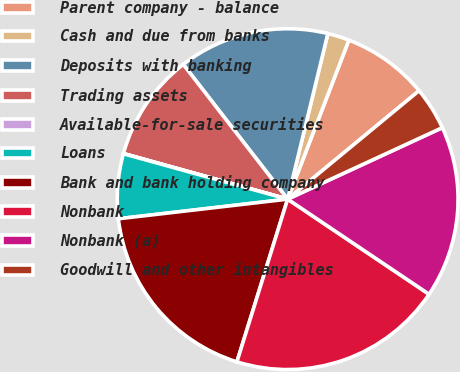<chart> <loc_0><loc_0><loc_500><loc_500><pie_chart><fcel>Parent company - balance<fcel>Cash and due from banks<fcel>Deposits with banking<fcel>Trading assets<fcel>Available-for-sale securities<fcel>Loans<fcel>Bank and bank holding company<fcel>Nonbank<fcel>Nonbank (a)<fcel>Goodwill and other intangibles<nl><fcel>8.17%<fcel>2.06%<fcel>14.28%<fcel>10.2%<fcel>0.02%<fcel>6.13%<fcel>18.35%<fcel>20.39%<fcel>16.31%<fcel>4.09%<nl></chart> 